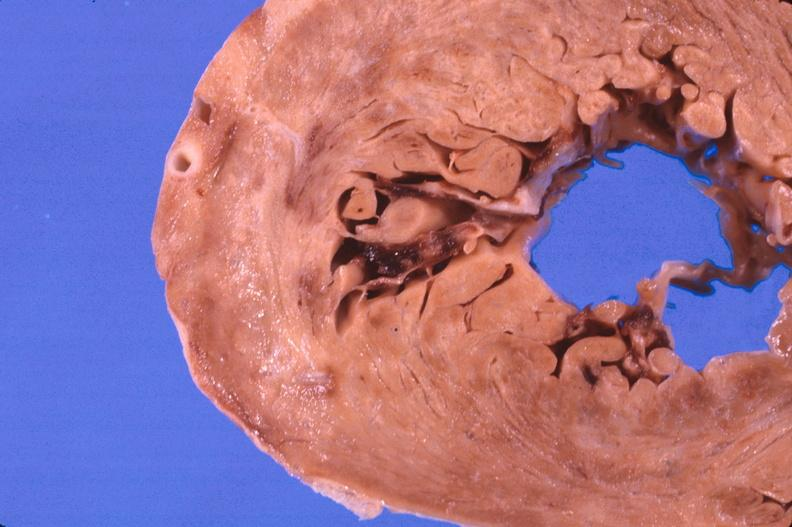does this image show heart, myocardial infarction free wall, 6 days old, in a patient with diabetes mellitus and hypertension?
Answer the question using a single word or phrase. Yes 